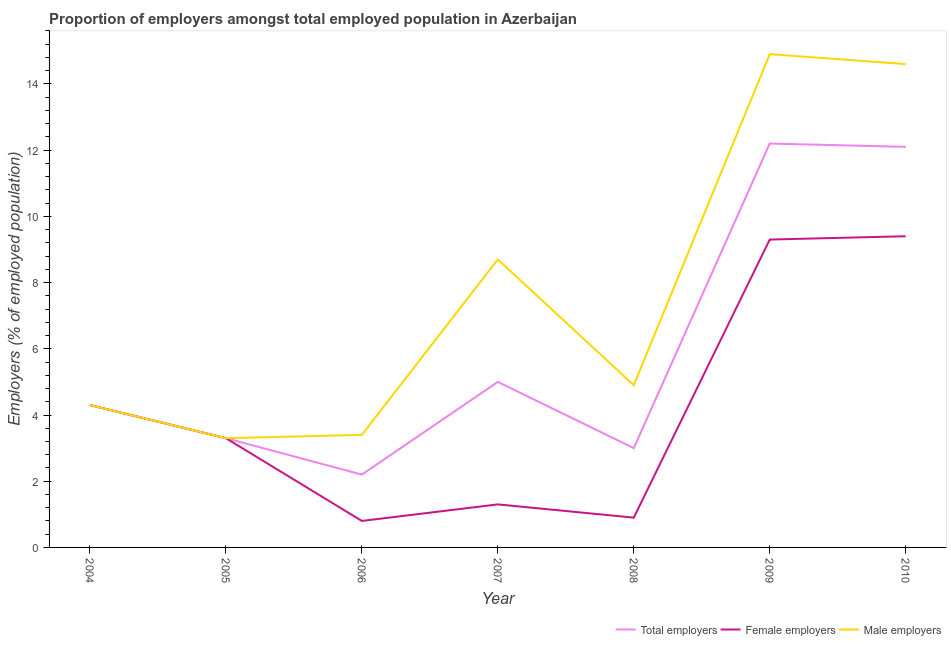How many different coloured lines are there?
Your response must be concise. 3. What is the percentage of male employers in 2008?
Provide a succinct answer. 4.9. Across all years, what is the maximum percentage of female employers?
Your answer should be compact. 9.4. Across all years, what is the minimum percentage of male employers?
Your response must be concise. 3.3. What is the total percentage of male employers in the graph?
Your answer should be very brief. 54.1. What is the difference between the percentage of female employers in 2004 and that in 2010?
Provide a short and direct response. -5.1. What is the difference between the percentage of female employers in 2010 and the percentage of male employers in 2008?
Your answer should be compact. 4.5. What is the average percentage of female employers per year?
Make the answer very short. 4.19. In the year 2009, what is the difference between the percentage of female employers and percentage of total employers?
Your response must be concise. -2.9. What is the ratio of the percentage of female employers in 2008 to that in 2010?
Offer a terse response. 0.1. What is the difference between the highest and the second highest percentage of male employers?
Your response must be concise. 0.3. What is the difference between the highest and the lowest percentage of female employers?
Offer a very short reply. 8.6. Does the percentage of female employers monotonically increase over the years?
Your answer should be compact. No. How many years are there in the graph?
Make the answer very short. 7. What is the difference between two consecutive major ticks on the Y-axis?
Your response must be concise. 2. Are the values on the major ticks of Y-axis written in scientific E-notation?
Give a very brief answer. No. How many legend labels are there?
Provide a succinct answer. 3. What is the title of the graph?
Provide a succinct answer. Proportion of employers amongst total employed population in Azerbaijan. What is the label or title of the Y-axis?
Give a very brief answer. Employers (% of employed population). What is the Employers (% of employed population) of Total employers in 2004?
Ensure brevity in your answer.  4.3. What is the Employers (% of employed population) in Female employers in 2004?
Make the answer very short. 4.3. What is the Employers (% of employed population) in Male employers in 2004?
Provide a succinct answer. 4.3. What is the Employers (% of employed population) in Total employers in 2005?
Offer a terse response. 3.3. What is the Employers (% of employed population) of Female employers in 2005?
Your response must be concise. 3.3. What is the Employers (% of employed population) in Male employers in 2005?
Your answer should be very brief. 3.3. What is the Employers (% of employed population) of Total employers in 2006?
Your answer should be very brief. 2.2. What is the Employers (% of employed population) of Female employers in 2006?
Your response must be concise. 0.8. What is the Employers (% of employed population) of Male employers in 2006?
Your answer should be very brief. 3.4. What is the Employers (% of employed population) in Female employers in 2007?
Your answer should be very brief. 1.3. What is the Employers (% of employed population) of Male employers in 2007?
Provide a succinct answer. 8.7. What is the Employers (% of employed population) in Total employers in 2008?
Give a very brief answer. 3. What is the Employers (% of employed population) in Female employers in 2008?
Your answer should be very brief. 0.9. What is the Employers (% of employed population) in Male employers in 2008?
Ensure brevity in your answer.  4.9. What is the Employers (% of employed population) of Total employers in 2009?
Give a very brief answer. 12.2. What is the Employers (% of employed population) in Female employers in 2009?
Ensure brevity in your answer.  9.3. What is the Employers (% of employed population) in Male employers in 2009?
Ensure brevity in your answer.  14.9. What is the Employers (% of employed population) in Total employers in 2010?
Provide a succinct answer. 12.1. What is the Employers (% of employed population) in Female employers in 2010?
Provide a succinct answer. 9.4. What is the Employers (% of employed population) in Male employers in 2010?
Offer a terse response. 14.6. Across all years, what is the maximum Employers (% of employed population) of Total employers?
Give a very brief answer. 12.2. Across all years, what is the maximum Employers (% of employed population) of Female employers?
Offer a terse response. 9.4. Across all years, what is the maximum Employers (% of employed population) of Male employers?
Offer a very short reply. 14.9. Across all years, what is the minimum Employers (% of employed population) in Total employers?
Make the answer very short. 2.2. Across all years, what is the minimum Employers (% of employed population) in Female employers?
Keep it short and to the point. 0.8. Across all years, what is the minimum Employers (% of employed population) of Male employers?
Provide a succinct answer. 3.3. What is the total Employers (% of employed population) in Total employers in the graph?
Provide a short and direct response. 42.1. What is the total Employers (% of employed population) in Female employers in the graph?
Your answer should be very brief. 29.3. What is the total Employers (% of employed population) in Male employers in the graph?
Give a very brief answer. 54.1. What is the difference between the Employers (% of employed population) of Male employers in 2004 and that in 2005?
Give a very brief answer. 1. What is the difference between the Employers (% of employed population) in Total employers in 2004 and that in 2006?
Give a very brief answer. 2.1. What is the difference between the Employers (% of employed population) of Male employers in 2004 and that in 2006?
Ensure brevity in your answer.  0.9. What is the difference between the Employers (% of employed population) in Total employers in 2004 and that in 2007?
Provide a short and direct response. -0.7. What is the difference between the Employers (% of employed population) of Female employers in 2004 and that in 2007?
Provide a succinct answer. 3. What is the difference between the Employers (% of employed population) in Total employers in 2004 and that in 2008?
Offer a very short reply. 1.3. What is the difference between the Employers (% of employed population) in Total employers in 2004 and that in 2010?
Your answer should be very brief. -7.8. What is the difference between the Employers (% of employed population) of Female employers in 2004 and that in 2010?
Your response must be concise. -5.1. What is the difference between the Employers (% of employed population) in Male employers in 2004 and that in 2010?
Make the answer very short. -10.3. What is the difference between the Employers (% of employed population) in Total employers in 2005 and that in 2006?
Provide a succinct answer. 1.1. What is the difference between the Employers (% of employed population) of Female employers in 2005 and that in 2006?
Offer a very short reply. 2.5. What is the difference between the Employers (% of employed population) in Male employers in 2005 and that in 2006?
Provide a short and direct response. -0.1. What is the difference between the Employers (% of employed population) of Male employers in 2005 and that in 2007?
Offer a very short reply. -5.4. What is the difference between the Employers (% of employed population) in Total employers in 2005 and that in 2008?
Offer a terse response. 0.3. What is the difference between the Employers (% of employed population) in Total employers in 2005 and that in 2010?
Ensure brevity in your answer.  -8.8. What is the difference between the Employers (% of employed population) of Male employers in 2005 and that in 2010?
Make the answer very short. -11.3. What is the difference between the Employers (% of employed population) in Total employers in 2006 and that in 2008?
Provide a short and direct response. -0.8. What is the difference between the Employers (% of employed population) in Female employers in 2006 and that in 2009?
Offer a terse response. -8.5. What is the difference between the Employers (% of employed population) of Total employers in 2006 and that in 2010?
Keep it short and to the point. -9.9. What is the difference between the Employers (% of employed population) in Total employers in 2007 and that in 2008?
Keep it short and to the point. 2. What is the difference between the Employers (% of employed population) of Total employers in 2007 and that in 2009?
Keep it short and to the point. -7.2. What is the difference between the Employers (% of employed population) in Female employers in 2007 and that in 2009?
Give a very brief answer. -8. What is the difference between the Employers (% of employed population) in Male employers in 2007 and that in 2009?
Ensure brevity in your answer.  -6.2. What is the difference between the Employers (% of employed population) of Female employers in 2007 and that in 2010?
Ensure brevity in your answer.  -8.1. What is the difference between the Employers (% of employed population) of Total employers in 2008 and that in 2009?
Your answer should be very brief. -9.2. What is the difference between the Employers (% of employed population) of Male employers in 2008 and that in 2010?
Your answer should be compact. -9.7. What is the difference between the Employers (% of employed population) in Total employers in 2009 and that in 2010?
Keep it short and to the point. 0.1. What is the difference between the Employers (% of employed population) in Female employers in 2009 and that in 2010?
Provide a short and direct response. -0.1. What is the difference between the Employers (% of employed population) of Male employers in 2009 and that in 2010?
Ensure brevity in your answer.  0.3. What is the difference between the Employers (% of employed population) in Total employers in 2004 and the Employers (% of employed population) in Female employers in 2005?
Your answer should be very brief. 1. What is the difference between the Employers (% of employed population) of Total employers in 2004 and the Employers (% of employed population) of Male employers in 2005?
Make the answer very short. 1. What is the difference between the Employers (% of employed population) of Female employers in 2004 and the Employers (% of employed population) of Male employers in 2005?
Offer a terse response. 1. What is the difference between the Employers (% of employed population) of Total employers in 2004 and the Employers (% of employed population) of Male employers in 2006?
Offer a very short reply. 0.9. What is the difference between the Employers (% of employed population) in Female employers in 2004 and the Employers (% of employed population) in Male employers in 2006?
Offer a very short reply. 0.9. What is the difference between the Employers (% of employed population) in Total employers in 2004 and the Employers (% of employed population) in Female employers in 2007?
Keep it short and to the point. 3. What is the difference between the Employers (% of employed population) in Female employers in 2004 and the Employers (% of employed population) in Male employers in 2007?
Offer a terse response. -4.4. What is the difference between the Employers (% of employed population) of Total employers in 2004 and the Employers (% of employed population) of Male employers in 2008?
Your response must be concise. -0.6. What is the difference between the Employers (% of employed population) of Female employers in 2004 and the Employers (% of employed population) of Male employers in 2008?
Make the answer very short. -0.6. What is the difference between the Employers (% of employed population) of Female employers in 2004 and the Employers (% of employed population) of Male employers in 2009?
Offer a very short reply. -10.6. What is the difference between the Employers (% of employed population) of Total employers in 2004 and the Employers (% of employed population) of Female employers in 2010?
Make the answer very short. -5.1. What is the difference between the Employers (% of employed population) in Total employers in 2004 and the Employers (% of employed population) in Male employers in 2010?
Your answer should be very brief. -10.3. What is the difference between the Employers (% of employed population) of Female employers in 2004 and the Employers (% of employed population) of Male employers in 2010?
Provide a short and direct response. -10.3. What is the difference between the Employers (% of employed population) of Total employers in 2005 and the Employers (% of employed population) of Female employers in 2006?
Provide a succinct answer. 2.5. What is the difference between the Employers (% of employed population) in Total employers in 2005 and the Employers (% of employed population) in Male employers in 2006?
Your answer should be compact. -0.1. What is the difference between the Employers (% of employed population) of Total employers in 2005 and the Employers (% of employed population) of Male employers in 2007?
Ensure brevity in your answer.  -5.4. What is the difference between the Employers (% of employed population) of Female employers in 2005 and the Employers (% of employed population) of Male employers in 2007?
Provide a short and direct response. -5.4. What is the difference between the Employers (% of employed population) of Total employers in 2005 and the Employers (% of employed population) of Male employers in 2008?
Your response must be concise. -1.6. What is the difference between the Employers (% of employed population) of Female employers in 2005 and the Employers (% of employed population) of Male employers in 2008?
Offer a terse response. -1.6. What is the difference between the Employers (% of employed population) of Total employers in 2005 and the Employers (% of employed population) of Female employers in 2010?
Your answer should be compact. -6.1. What is the difference between the Employers (% of employed population) of Female employers in 2005 and the Employers (% of employed population) of Male employers in 2010?
Your answer should be very brief. -11.3. What is the difference between the Employers (% of employed population) in Total employers in 2006 and the Employers (% of employed population) in Female employers in 2007?
Your answer should be compact. 0.9. What is the difference between the Employers (% of employed population) of Total employers in 2006 and the Employers (% of employed population) of Male employers in 2008?
Your answer should be compact. -2.7. What is the difference between the Employers (% of employed population) in Female employers in 2006 and the Employers (% of employed population) in Male employers in 2008?
Provide a succinct answer. -4.1. What is the difference between the Employers (% of employed population) in Total employers in 2006 and the Employers (% of employed population) in Female employers in 2009?
Your answer should be very brief. -7.1. What is the difference between the Employers (% of employed population) in Female employers in 2006 and the Employers (% of employed population) in Male employers in 2009?
Give a very brief answer. -14.1. What is the difference between the Employers (% of employed population) in Total employers in 2006 and the Employers (% of employed population) in Female employers in 2010?
Offer a terse response. -7.2. What is the difference between the Employers (% of employed population) of Total employers in 2006 and the Employers (% of employed population) of Male employers in 2010?
Your response must be concise. -12.4. What is the difference between the Employers (% of employed population) of Female employers in 2006 and the Employers (% of employed population) of Male employers in 2010?
Ensure brevity in your answer.  -13.8. What is the difference between the Employers (% of employed population) of Total employers in 2007 and the Employers (% of employed population) of Female employers in 2008?
Offer a terse response. 4.1. What is the difference between the Employers (% of employed population) in Female employers in 2007 and the Employers (% of employed population) in Male employers in 2010?
Provide a succinct answer. -13.3. What is the difference between the Employers (% of employed population) in Total employers in 2008 and the Employers (% of employed population) in Female employers in 2009?
Your response must be concise. -6.3. What is the difference between the Employers (% of employed population) of Total employers in 2008 and the Employers (% of employed population) of Male employers in 2009?
Provide a succinct answer. -11.9. What is the difference between the Employers (% of employed population) in Female employers in 2008 and the Employers (% of employed population) in Male employers in 2009?
Offer a very short reply. -14. What is the difference between the Employers (% of employed population) of Total employers in 2008 and the Employers (% of employed population) of Female employers in 2010?
Keep it short and to the point. -6.4. What is the difference between the Employers (% of employed population) in Female employers in 2008 and the Employers (% of employed population) in Male employers in 2010?
Your response must be concise. -13.7. What is the difference between the Employers (% of employed population) of Total employers in 2009 and the Employers (% of employed population) of Female employers in 2010?
Ensure brevity in your answer.  2.8. What is the difference between the Employers (% of employed population) in Total employers in 2009 and the Employers (% of employed population) in Male employers in 2010?
Make the answer very short. -2.4. What is the average Employers (% of employed population) in Total employers per year?
Offer a terse response. 6.01. What is the average Employers (% of employed population) of Female employers per year?
Offer a terse response. 4.19. What is the average Employers (% of employed population) in Male employers per year?
Offer a terse response. 7.73. In the year 2005, what is the difference between the Employers (% of employed population) of Female employers and Employers (% of employed population) of Male employers?
Ensure brevity in your answer.  0. In the year 2006, what is the difference between the Employers (% of employed population) in Female employers and Employers (% of employed population) in Male employers?
Offer a very short reply. -2.6. In the year 2007, what is the difference between the Employers (% of employed population) of Female employers and Employers (% of employed population) of Male employers?
Provide a short and direct response. -7.4. In the year 2008, what is the difference between the Employers (% of employed population) in Total employers and Employers (% of employed population) in Female employers?
Ensure brevity in your answer.  2.1. In the year 2008, what is the difference between the Employers (% of employed population) in Total employers and Employers (% of employed population) in Male employers?
Keep it short and to the point. -1.9. In the year 2009, what is the difference between the Employers (% of employed population) in Total employers and Employers (% of employed population) in Male employers?
Make the answer very short. -2.7. In the year 2009, what is the difference between the Employers (% of employed population) of Female employers and Employers (% of employed population) of Male employers?
Give a very brief answer. -5.6. In the year 2010, what is the difference between the Employers (% of employed population) of Total employers and Employers (% of employed population) of Female employers?
Your answer should be very brief. 2.7. In the year 2010, what is the difference between the Employers (% of employed population) of Female employers and Employers (% of employed population) of Male employers?
Offer a very short reply. -5.2. What is the ratio of the Employers (% of employed population) in Total employers in 2004 to that in 2005?
Ensure brevity in your answer.  1.3. What is the ratio of the Employers (% of employed population) of Female employers in 2004 to that in 2005?
Provide a succinct answer. 1.3. What is the ratio of the Employers (% of employed population) of Male employers in 2004 to that in 2005?
Your response must be concise. 1.3. What is the ratio of the Employers (% of employed population) in Total employers in 2004 to that in 2006?
Give a very brief answer. 1.95. What is the ratio of the Employers (% of employed population) in Female employers in 2004 to that in 2006?
Your response must be concise. 5.38. What is the ratio of the Employers (% of employed population) in Male employers in 2004 to that in 2006?
Your answer should be compact. 1.26. What is the ratio of the Employers (% of employed population) of Total employers in 2004 to that in 2007?
Give a very brief answer. 0.86. What is the ratio of the Employers (% of employed population) of Female employers in 2004 to that in 2007?
Keep it short and to the point. 3.31. What is the ratio of the Employers (% of employed population) of Male employers in 2004 to that in 2007?
Give a very brief answer. 0.49. What is the ratio of the Employers (% of employed population) in Total employers in 2004 to that in 2008?
Offer a very short reply. 1.43. What is the ratio of the Employers (% of employed population) in Female employers in 2004 to that in 2008?
Keep it short and to the point. 4.78. What is the ratio of the Employers (% of employed population) in Male employers in 2004 to that in 2008?
Your answer should be compact. 0.88. What is the ratio of the Employers (% of employed population) of Total employers in 2004 to that in 2009?
Offer a terse response. 0.35. What is the ratio of the Employers (% of employed population) in Female employers in 2004 to that in 2009?
Your answer should be very brief. 0.46. What is the ratio of the Employers (% of employed population) of Male employers in 2004 to that in 2009?
Your answer should be very brief. 0.29. What is the ratio of the Employers (% of employed population) of Total employers in 2004 to that in 2010?
Provide a short and direct response. 0.36. What is the ratio of the Employers (% of employed population) in Female employers in 2004 to that in 2010?
Your answer should be compact. 0.46. What is the ratio of the Employers (% of employed population) in Male employers in 2004 to that in 2010?
Keep it short and to the point. 0.29. What is the ratio of the Employers (% of employed population) of Total employers in 2005 to that in 2006?
Your answer should be compact. 1.5. What is the ratio of the Employers (% of employed population) in Female employers in 2005 to that in 2006?
Give a very brief answer. 4.12. What is the ratio of the Employers (% of employed population) in Male employers in 2005 to that in 2006?
Your answer should be very brief. 0.97. What is the ratio of the Employers (% of employed population) of Total employers in 2005 to that in 2007?
Give a very brief answer. 0.66. What is the ratio of the Employers (% of employed population) of Female employers in 2005 to that in 2007?
Your answer should be compact. 2.54. What is the ratio of the Employers (% of employed population) of Male employers in 2005 to that in 2007?
Provide a short and direct response. 0.38. What is the ratio of the Employers (% of employed population) in Female employers in 2005 to that in 2008?
Provide a short and direct response. 3.67. What is the ratio of the Employers (% of employed population) in Male employers in 2005 to that in 2008?
Provide a succinct answer. 0.67. What is the ratio of the Employers (% of employed population) of Total employers in 2005 to that in 2009?
Give a very brief answer. 0.27. What is the ratio of the Employers (% of employed population) in Female employers in 2005 to that in 2009?
Ensure brevity in your answer.  0.35. What is the ratio of the Employers (% of employed population) of Male employers in 2005 to that in 2009?
Provide a succinct answer. 0.22. What is the ratio of the Employers (% of employed population) of Total employers in 2005 to that in 2010?
Ensure brevity in your answer.  0.27. What is the ratio of the Employers (% of employed population) in Female employers in 2005 to that in 2010?
Provide a succinct answer. 0.35. What is the ratio of the Employers (% of employed population) in Male employers in 2005 to that in 2010?
Keep it short and to the point. 0.23. What is the ratio of the Employers (% of employed population) of Total employers in 2006 to that in 2007?
Make the answer very short. 0.44. What is the ratio of the Employers (% of employed population) of Female employers in 2006 to that in 2007?
Keep it short and to the point. 0.62. What is the ratio of the Employers (% of employed population) of Male employers in 2006 to that in 2007?
Keep it short and to the point. 0.39. What is the ratio of the Employers (% of employed population) of Total employers in 2006 to that in 2008?
Offer a terse response. 0.73. What is the ratio of the Employers (% of employed population) of Male employers in 2006 to that in 2008?
Offer a terse response. 0.69. What is the ratio of the Employers (% of employed population) in Total employers in 2006 to that in 2009?
Offer a terse response. 0.18. What is the ratio of the Employers (% of employed population) in Female employers in 2006 to that in 2009?
Offer a terse response. 0.09. What is the ratio of the Employers (% of employed population) of Male employers in 2006 to that in 2009?
Offer a very short reply. 0.23. What is the ratio of the Employers (% of employed population) in Total employers in 2006 to that in 2010?
Make the answer very short. 0.18. What is the ratio of the Employers (% of employed population) of Female employers in 2006 to that in 2010?
Give a very brief answer. 0.09. What is the ratio of the Employers (% of employed population) in Male employers in 2006 to that in 2010?
Keep it short and to the point. 0.23. What is the ratio of the Employers (% of employed population) in Female employers in 2007 to that in 2008?
Provide a succinct answer. 1.44. What is the ratio of the Employers (% of employed population) in Male employers in 2007 to that in 2008?
Offer a very short reply. 1.78. What is the ratio of the Employers (% of employed population) of Total employers in 2007 to that in 2009?
Offer a terse response. 0.41. What is the ratio of the Employers (% of employed population) in Female employers in 2007 to that in 2009?
Your response must be concise. 0.14. What is the ratio of the Employers (% of employed population) of Male employers in 2007 to that in 2009?
Give a very brief answer. 0.58. What is the ratio of the Employers (% of employed population) of Total employers in 2007 to that in 2010?
Provide a short and direct response. 0.41. What is the ratio of the Employers (% of employed population) in Female employers in 2007 to that in 2010?
Your answer should be very brief. 0.14. What is the ratio of the Employers (% of employed population) of Male employers in 2007 to that in 2010?
Offer a terse response. 0.6. What is the ratio of the Employers (% of employed population) of Total employers in 2008 to that in 2009?
Offer a terse response. 0.25. What is the ratio of the Employers (% of employed population) in Female employers in 2008 to that in 2009?
Provide a short and direct response. 0.1. What is the ratio of the Employers (% of employed population) of Male employers in 2008 to that in 2009?
Offer a terse response. 0.33. What is the ratio of the Employers (% of employed population) of Total employers in 2008 to that in 2010?
Ensure brevity in your answer.  0.25. What is the ratio of the Employers (% of employed population) in Female employers in 2008 to that in 2010?
Your response must be concise. 0.1. What is the ratio of the Employers (% of employed population) in Male employers in 2008 to that in 2010?
Give a very brief answer. 0.34. What is the ratio of the Employers (% of employed population) of Total employers in 2009 to that in 2010?
Ensure brevity in your answer.  1.01. What is the ratio of the Employers (% of employed population) of Male employers in 2009 to that in 2010?
Ensure brevity in your answer.  1.02. What is the difference between the highest and the second highest Employers (% of employed population) in Female employers?
Ensure brevity in your answer.  0.1. What is the difference between the highest and the lowest Employers (% of employed population) in Female employers?
Ensure brevity in your answer.  8.6. What is the difference between the highest and the lowest Employers (% of employed population) in Male employers?
Keep it short and to the point. 11.6. 